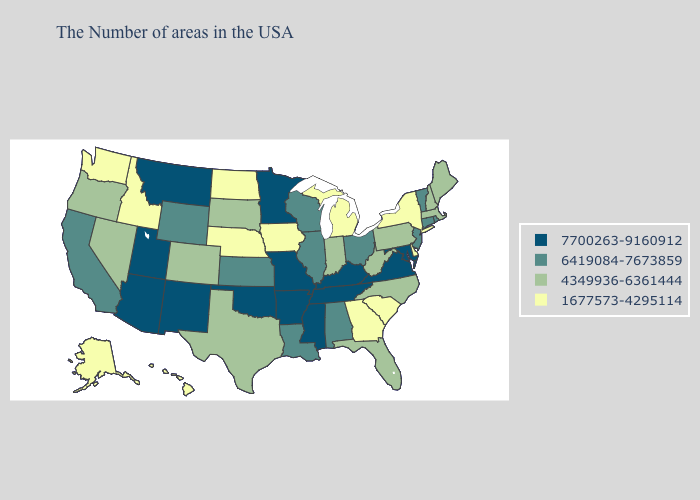What is the value of Illinois?
Answer briefly. 6419084-7673859. What is the highest value in the Northeast ?
Write a very short answer. 6419084-7673859. Name the states that have a value in the range 6419084-7673859?
Write a very short answer. Rhode Island, Vermont, Connecticut, New Jersey, Ohio, Alabama, Wisconsin, Illinois, Louisiana, Kansas, Wyoming, California. Which states have the lowest value in the USA?
Quick response, please. New York, Delaware, South Carolina, Georgia, Michigan, Iowa, Nebraska, North Dakota, Idaho, Washington, Alaska, Hawaii. Among the states that border Kansas , does Oklahoma have the highest value?
Quick response, please. Yes. Does Vermont have the lowest value in the USA?
Be succinct. No. Which states have the lowest value in the USA?
Concise answer only. New York, Delaware, South Carolina, Georgia, Michigan, Iowa, Nebraska, North Dakota, Idaho, Washington, Alaska, Hawaii. Which states hav the highest value in the West?
Short answer required. New Mexico, Utah, Montana, Arizona. Name the states that have a value in the range 4349936-6361444?
Concise answer only. Maine, Massachusetts, New Hampshire, Pennsylvania, North Carolina, West Virginia, Florida, Indiana, Texas, South Dakota, Colorado, Nevada, Oregon. What is the value of North Dakota?
Answer briefly. 1677573-4295114. Name the states that have a value in the range 4349936-6361444?
Answer briefly. Maine, Massachusetts, New Hampshire, Pennsylvania, North Carolina, West Virginia, Florida, Indiana, Texas, South Dakota, Colorado, Nevada, Oregon. What is the highest value in the USA?
Answer briefly. 7700263-9160912. What is the highest value in the USA?
Give a very brief answer. 7700263-9160912. What is the value of Alaska?
Give a very brief answer. 1677573-4295114. Which states have the lowest value in the MidWest?
Keep it brief. Michigan, Iowa, Nebraska, North Dakota. 